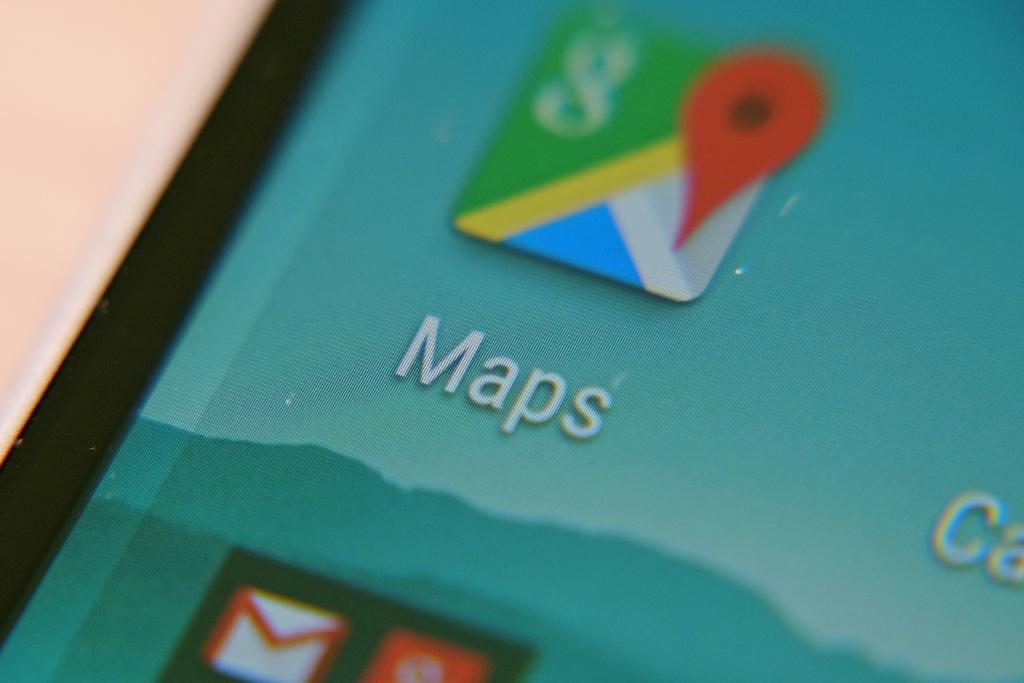<image>
Summarize the visual content of the image. A smart phone with a smokey, blue mountain range in the background and the Maps app in the foreground. 